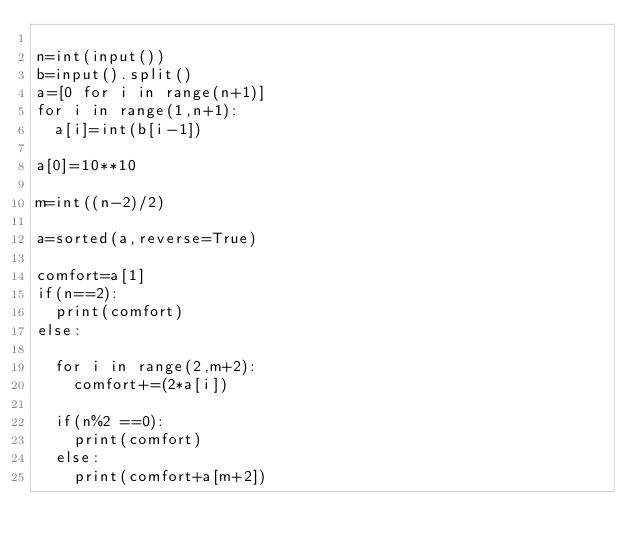Convert code to text. <code><loc_0><loc_0><loc_500><loc_500><_Python_>
n=int(input())
b=input().split()
a=[0 for i in range(n+1)]
for i in range(1,n+1):
  a[i]=int(b[i-1])

a[0]=10**10

m=int((n-2)/2)

a=sorted(a,reverse=True)

comfort=a[1]
if(n==2):
  print(comfort)
else:
  
  for i in range(2,m+2):
    comfort+=(2*a[i])

  if(n%2 ==0):
    print(comfort)
  else:
    print(comfort+a[m+2])

</code> 